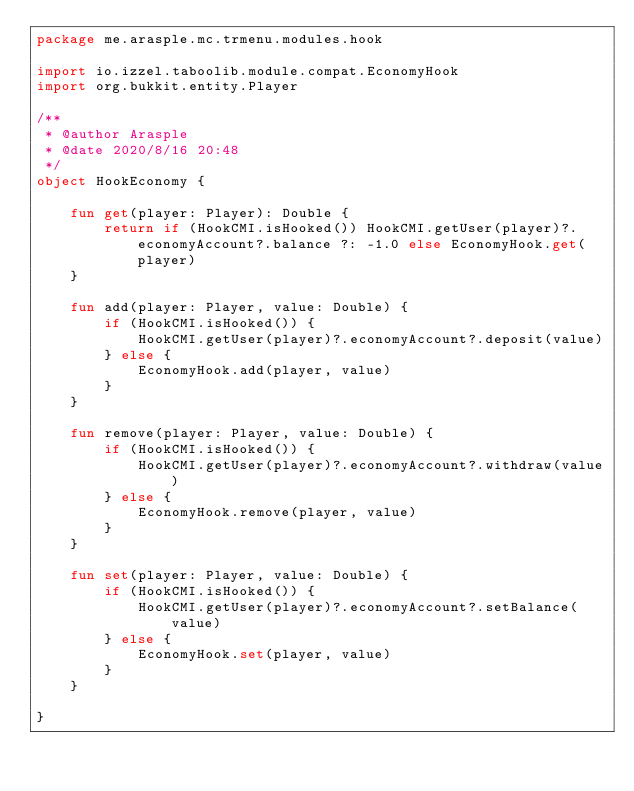<code> <loc_0><loc_0><loc_500><loc_500><_Kotlin_>package me.arasple.mc.trmenu.modules.hook

import io.izzel.taboolib.module.compat.EconomyHook
import org.bukkit.entity.Player

/**
 * @author Arasple
 * @date 2020/8/16 20:48
 */
object HookEconomy {

    fun get(player: Player): Double {
        return if (HookCMI.isHooked()) HookCMI.getUser(player)?.economyAccount?.balance ?: -1.0 else EconomyHook.get(player)
    }

    fun add(player: Player, value: Double) {
        if (HookCMI.isHooked()) {
            HookCMI.getUser(player)?.economyAccount?.deposit(value)
        } else {
            EconomyHook.add(player, value)
        }
    }

    fun remove(player: Player, value: Double) {
        if (HookCMI.isHooked()) {
            HookCMI.getUser(player)?.economyAccount?.withdraw(value)
        } else {
            EconomyHook.remove(player, value)
        }
    }

    fun set(player: Player, value: Double) {
        if (HookCMI.isHooked()) {
            HookCMI.getUser(player)?.economyAccount?.setBalance(value)
        } else {
            EconomyHook.set(player, value)
        }
    }

}</code> 